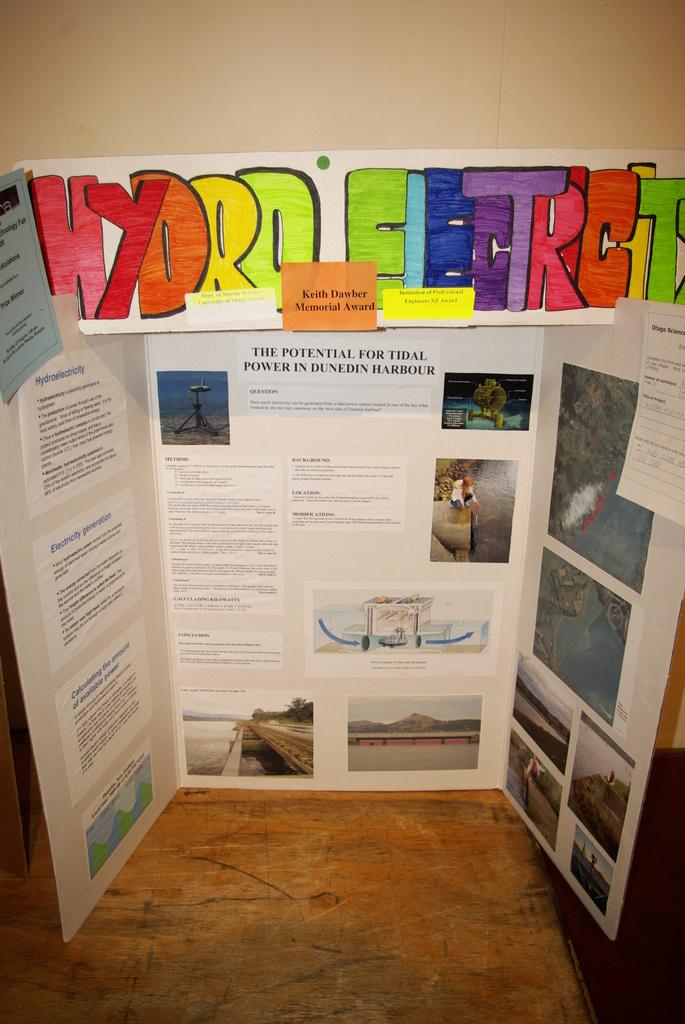<image>
Summarize the visual content of the image. Inside display for hydro electric by a student project 